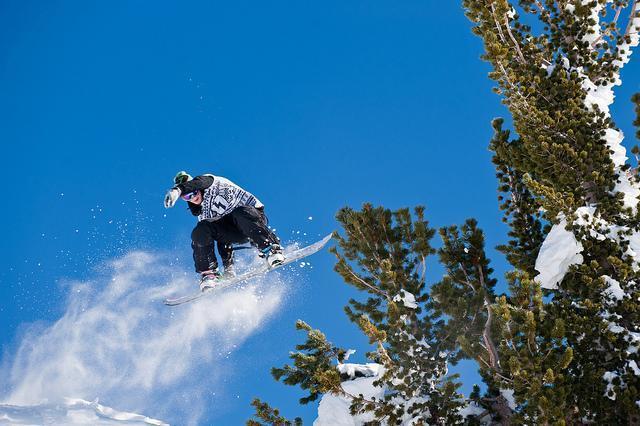How many clouds are in the sky?
Give a very brief answer. 0. How many horses are there?
Give a very brief answer. 0. 